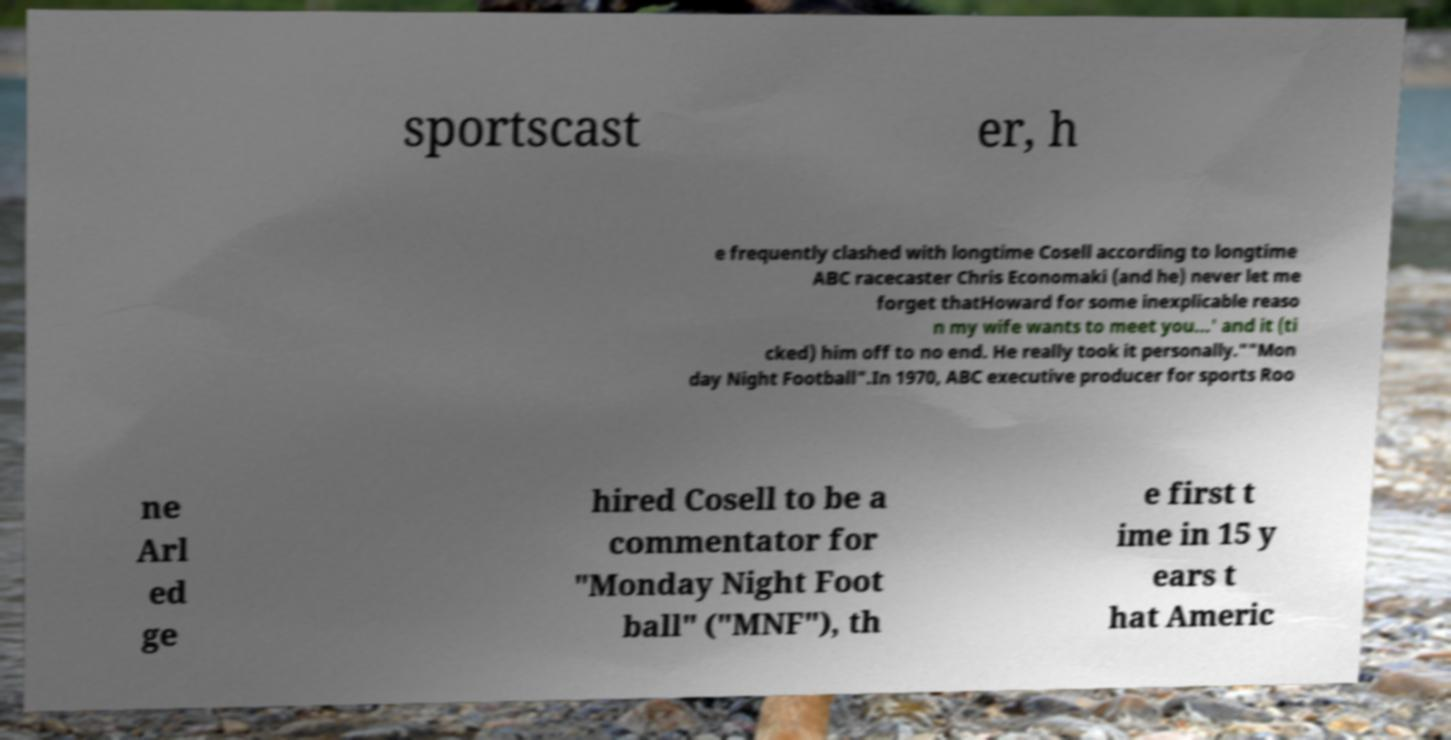Could you assist in decoding the text presented in this image and type it out clearly? sportscast er, h e frequently clashed with longtime Cosell according to longtime ABC racecaster Chris Economaki (and he) never let me forget thatHoward for some inexplicable reaso n my wife wants to meet you...' and it (ti cked) him off to no end. He really took it personally.""Mon day Night Football".In 1970, ABC executive producer for sports Roo ne Arl ed ge hired Cosell to be a commentator for "Monday Night Foot ball" ("MNF"), th e first t ime in 15 y ears t hat Americ 